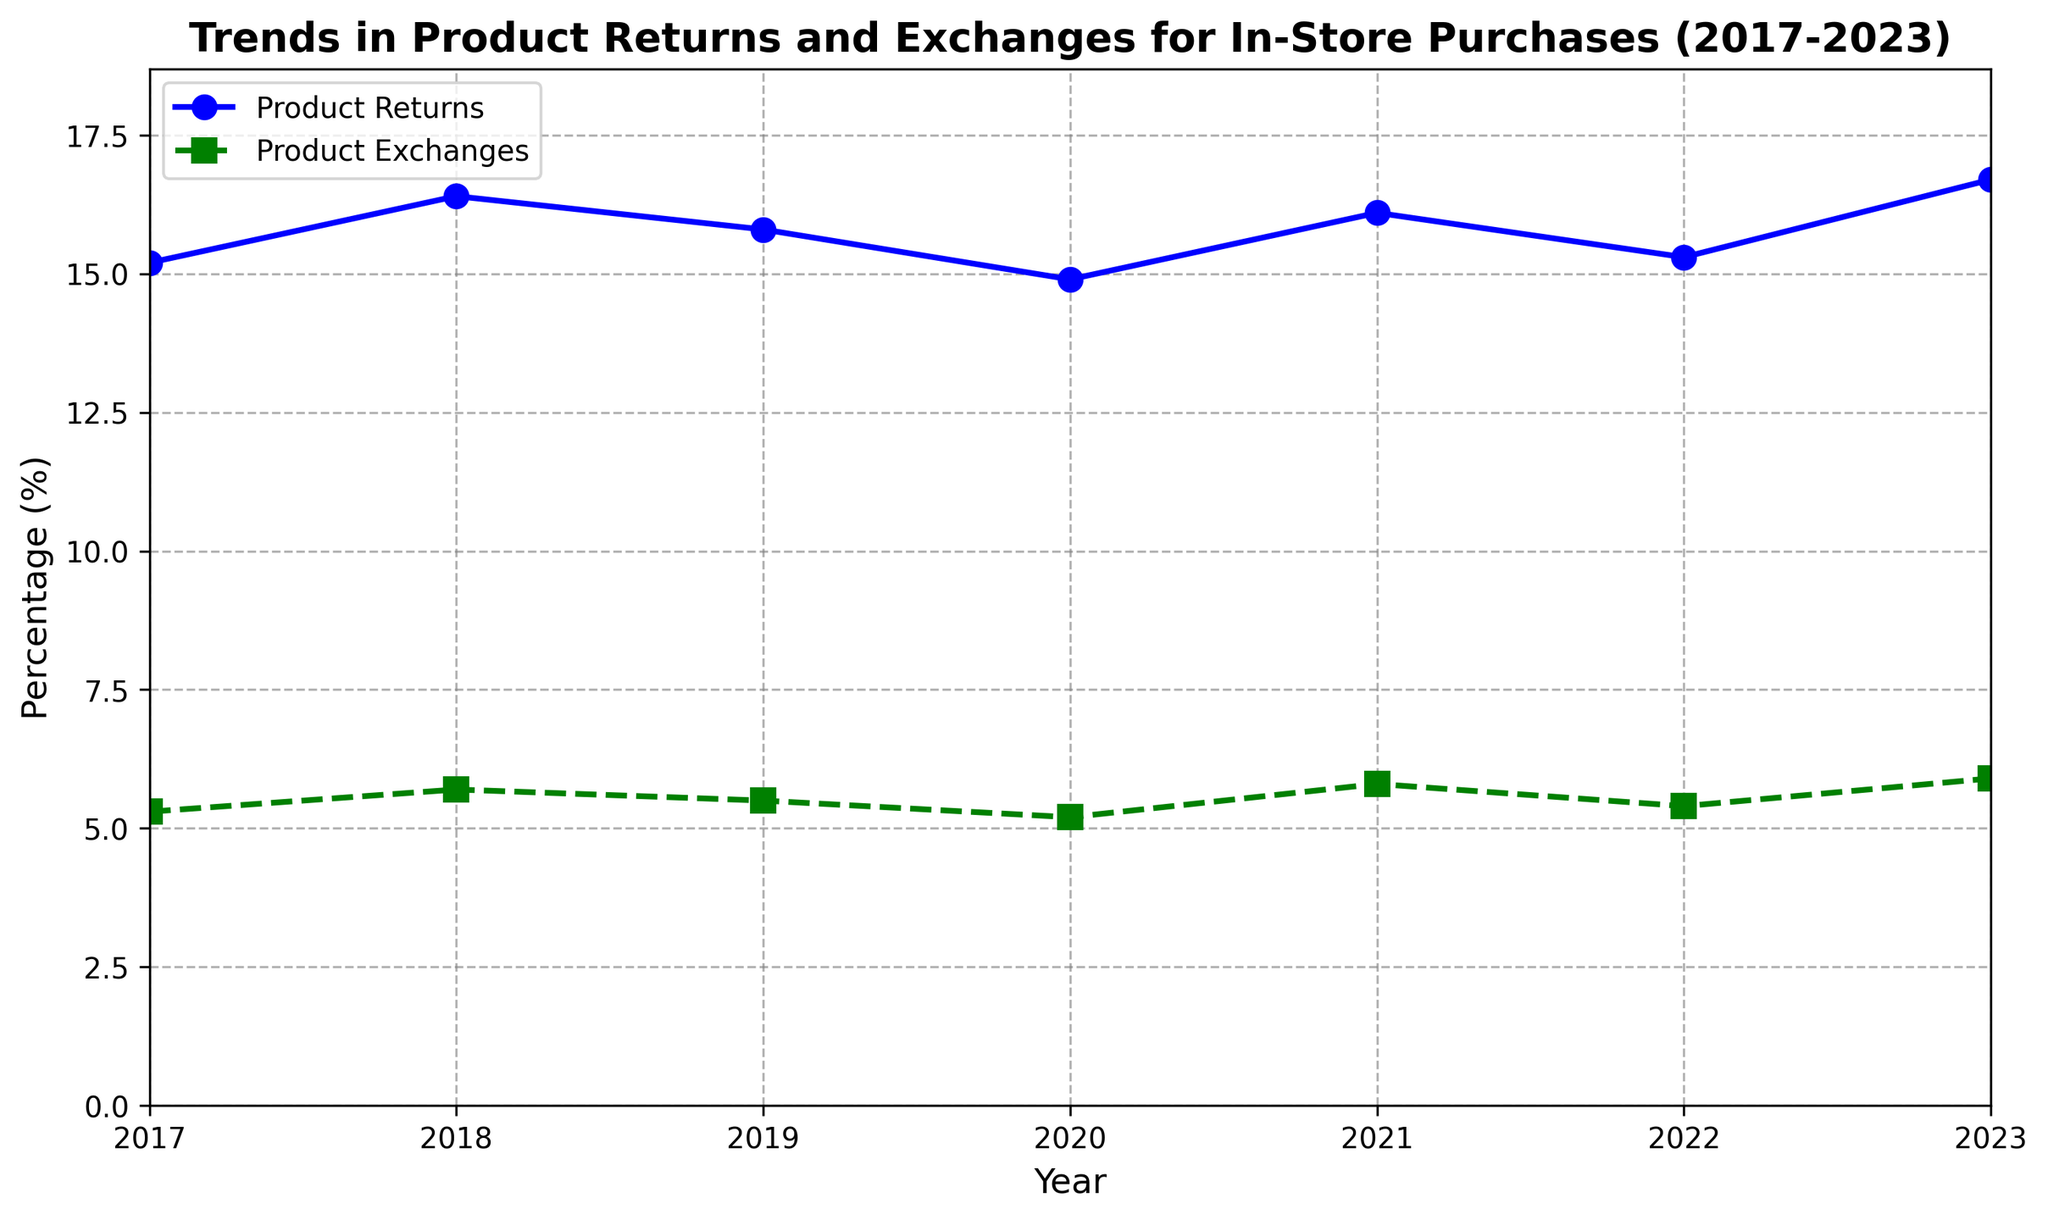What is the trend of product returns from 2017 to 2023? To determine the trend, observe the line representing product returns over the years. The data shows an overall slightly increasing trend, with values fluctuating between 14.9% (2020) and 16.7% (2023) over the period.
Answer: Slightly increasing In which year was the percentage of product exchanges the highest? Look at the green dashed line representing product exchanges and find the highest point. The highest value is 5.9% in 2023.
Answer: 2023 Which year had the lowest percentage of product returns? Identify the lowest point on the blue line representing product returns. The lowest percentage, 14.9%, occurred in 2020.
Answer: 2020 By how much did the percentage of product returns change from 2022 to 2023? Find the values for product returns in 2022 (15.3%) and 2023 (16.7%), then calculate the difference: 16.7% - 15.3% = 1.4%.
Answer: 1.4% Was there any year where both product returns and exchanges increased compared to the previous year? Examine the plot for each year to see if both lines increase compared to the previous year. Both product returns and exchanges increased from 2022 to 2023.
Answer: 2022 to 2023 What is the average percentage of product exchanges over the seven years? Sum all the product exchange values: 5.3 + 5.7 + 5.5 + 5.2 + 5.8 + 5.4 + 5.9 = 38.8, then divide by 7: 38.8 / 7 = 5.54%.
Answer: 5.54% Did product returns ever exceed 16% in the given period? Check if the blue line for product returns crosses the 16% mark. The product returns exceed 16% in 2018 (16.4%), 2021 (16.1%), and 2023 (16.7%).
Answer: Yes Compare the trend of product exchanges to product returns over the years 2017-2023. Observe the patterns of the blue and green lines. Product returns fluctuate but show a slight overall increase, especially peaking in 2023. Product exchanges also show a generally increasing trend but with smaller fluctuations.
Answer: Both increased, returns more fluctuating What was the percentage difference between product returns and exchanges in 2023? Find the values for 2023: product returns (16.7%) and product exchanges (5.9%). Then calculate the difference: 16.7% - 5.9% = 10.8%.
Answer: 10.8% Calculate the sum of the percentages of product returns and exchanges in 2021. Add the values for 2021: product returns (16.1%) and product exchanges (5.8%). Their sum is 16.1 + 5.8 = 21.9%.
Answer: 21.9% 